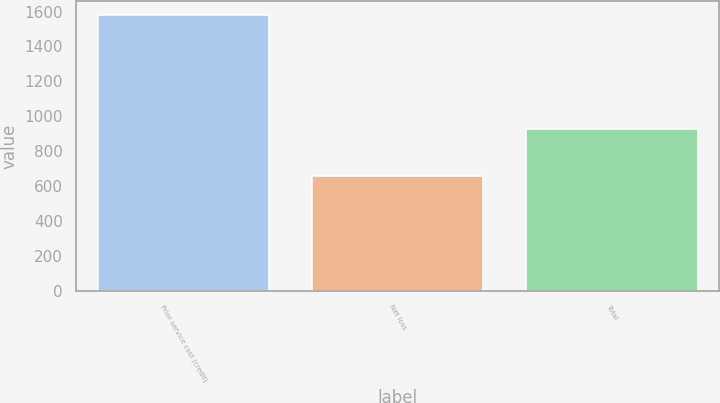Convert chart to OTSL. <chart><loc_0><loc_0><loc_500><loc_500><bar_chart><fcel>Prior service cost (credit)<fcel>Net loss<fcel>Total<nl><fcel>1580<fcel>655<fcel>925<nl></chart> 